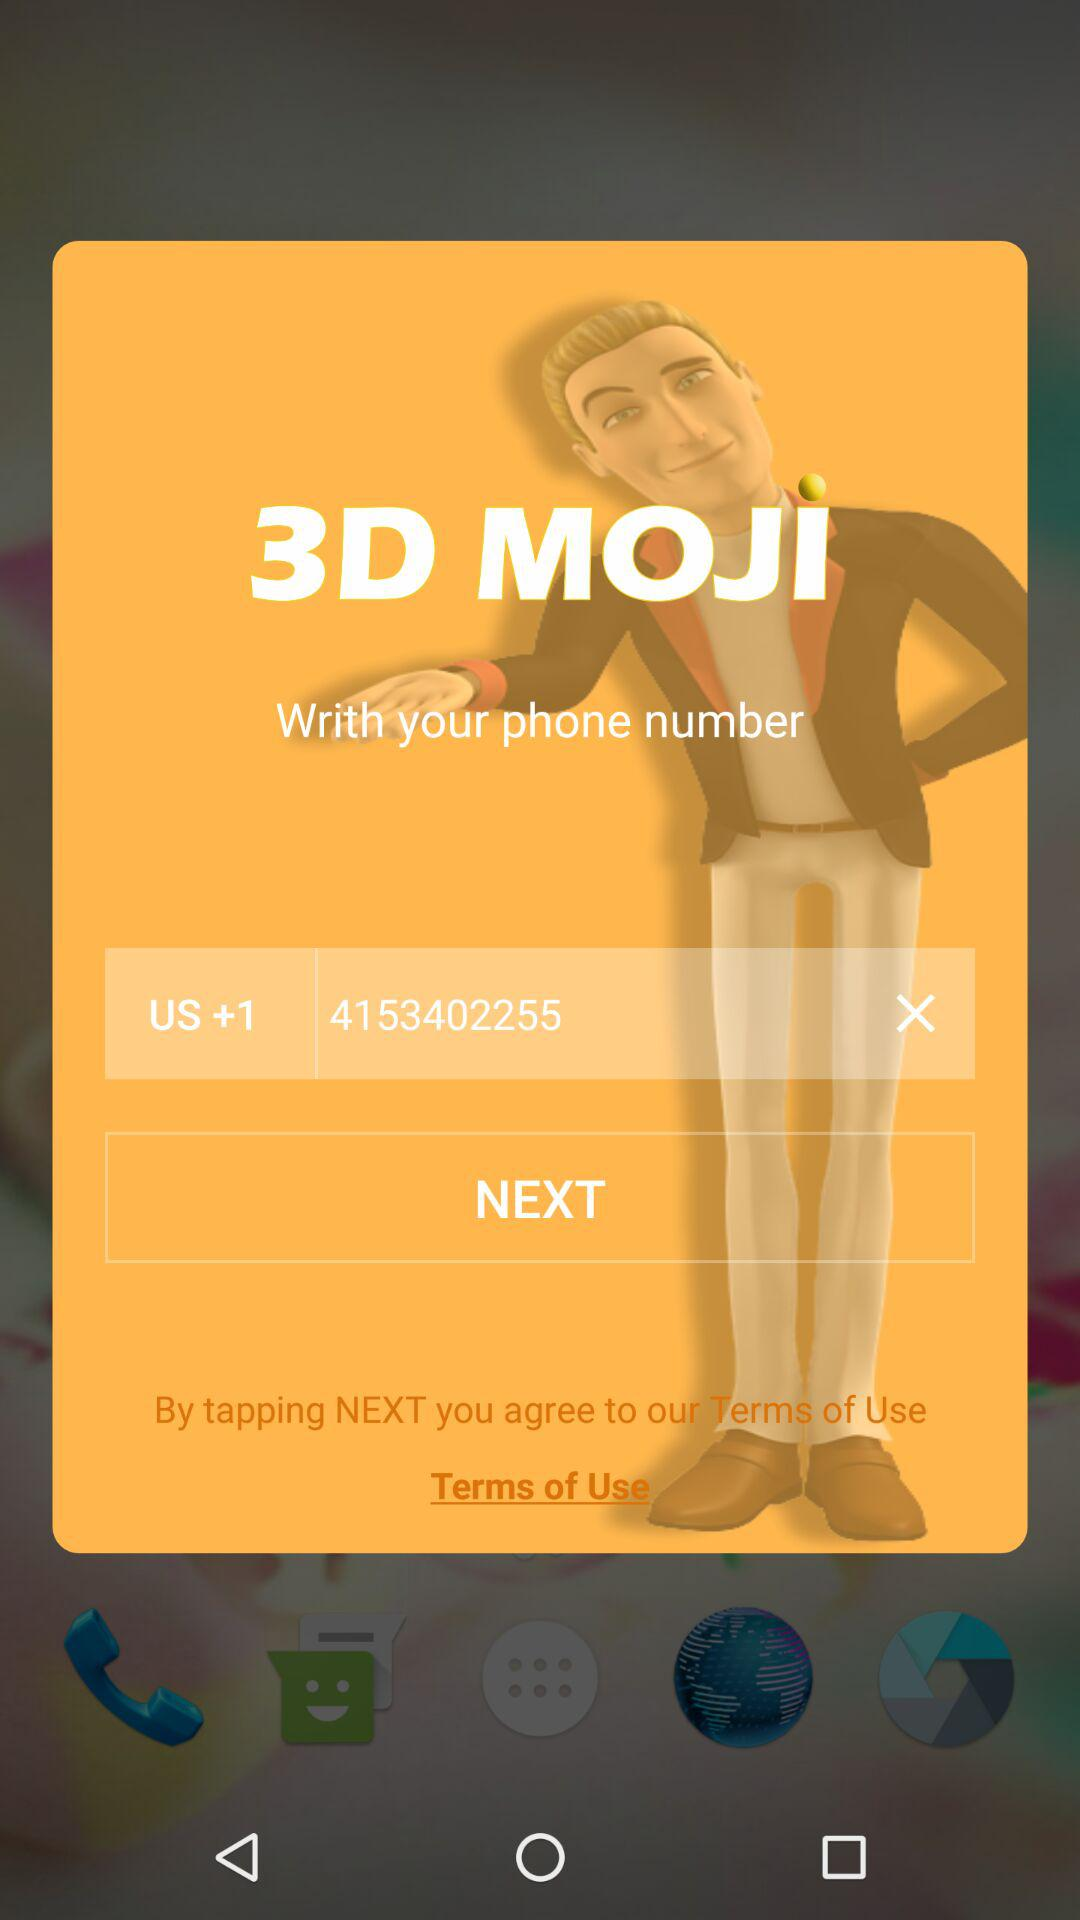What is the contact number? The contact number is +14253402255. 